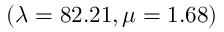<formula> <loc_0><loc_0><loc_500><loc_500>( \lambda = 8 2 . 2 1 , \mu = 1 . 6 8 )</formula> 